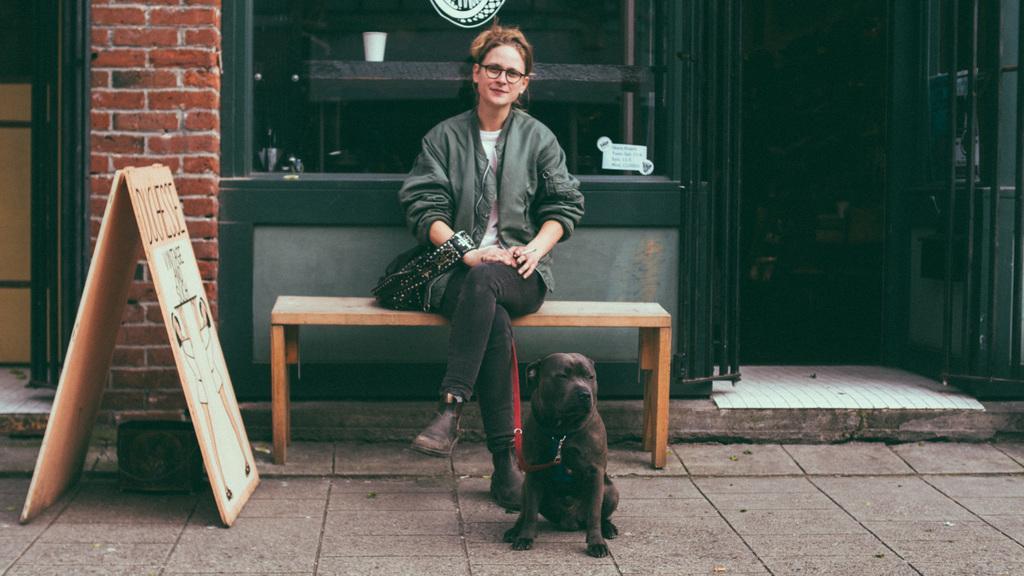Describe this image in one or two sentences. In this image the woman is sitting on the bench. The dog is sitting on the floor. At the back side there is a building. 